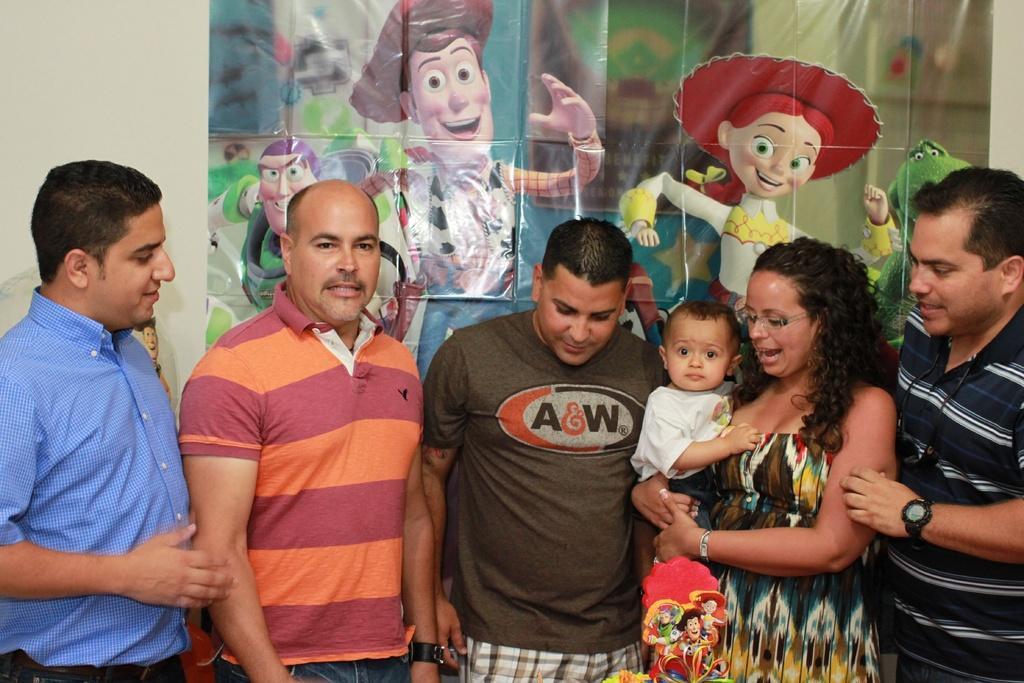Describe this image in one or two sentences. Here I can see few men and a woman are standing. The woman is carrying a baby in the hands and looking at the downwards. At the bottom of the image there is a cake. At the back of these people there is a banner which consists of cartoon images on it and this banner is attached to the wall. 